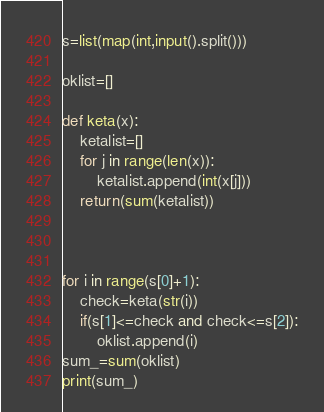<code> <loc_0><loc_0><loc_500><loc_500><_Python_>s=list(map(int,input().split()))

oklist=[]

def keta(x):
    ketalist=[]
    for j in range(len(x)):
        ketalist.append(int(x[j]))
    return(sum(ketalist))
        
    

for i in range(s[0]+1):
    check=keta(str(i))
    if(s[1]<=check and check<=s[2]):
        oklist.append(i)     
sum_=sum(oklist)
print(sum_)</code> 